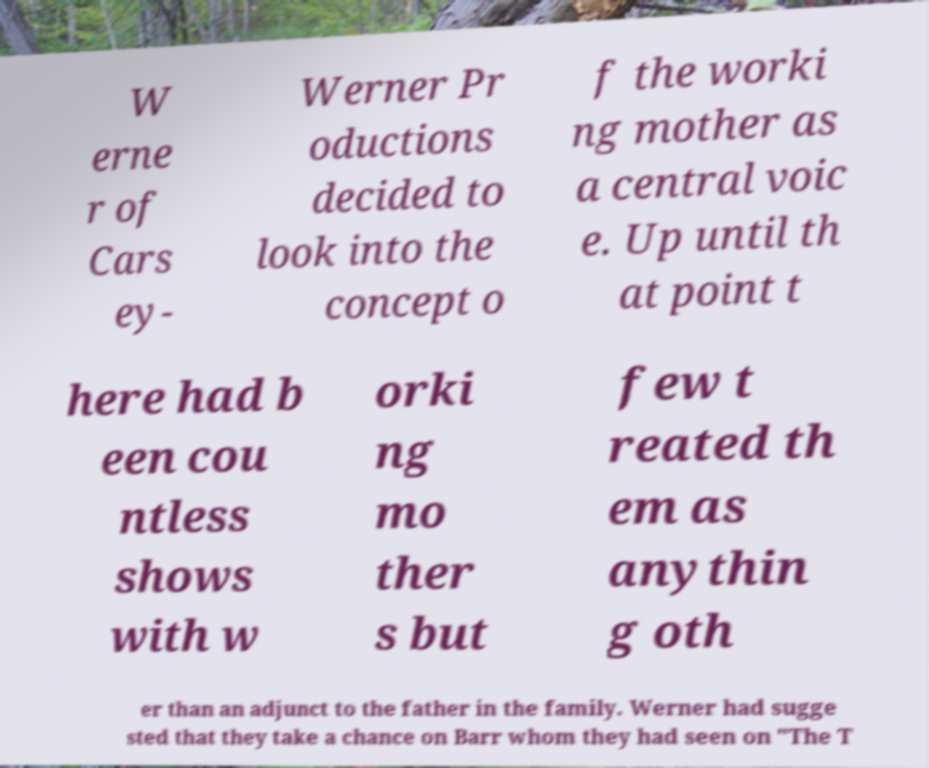I need the written content from this picture converted into text. Can you do that? W erne r of Cars ey- Werner Pr oductions decided to look into the concept o f the worki ng mother as a central voic e. Up until th at point t here had b een cou ntless shows with w orki ng mo ther s but few t reated th em as anythin g oth er than an adjunct to the father in the family. Werner had sugge sted that they take a chance on Barr whom they had seen on "The T 